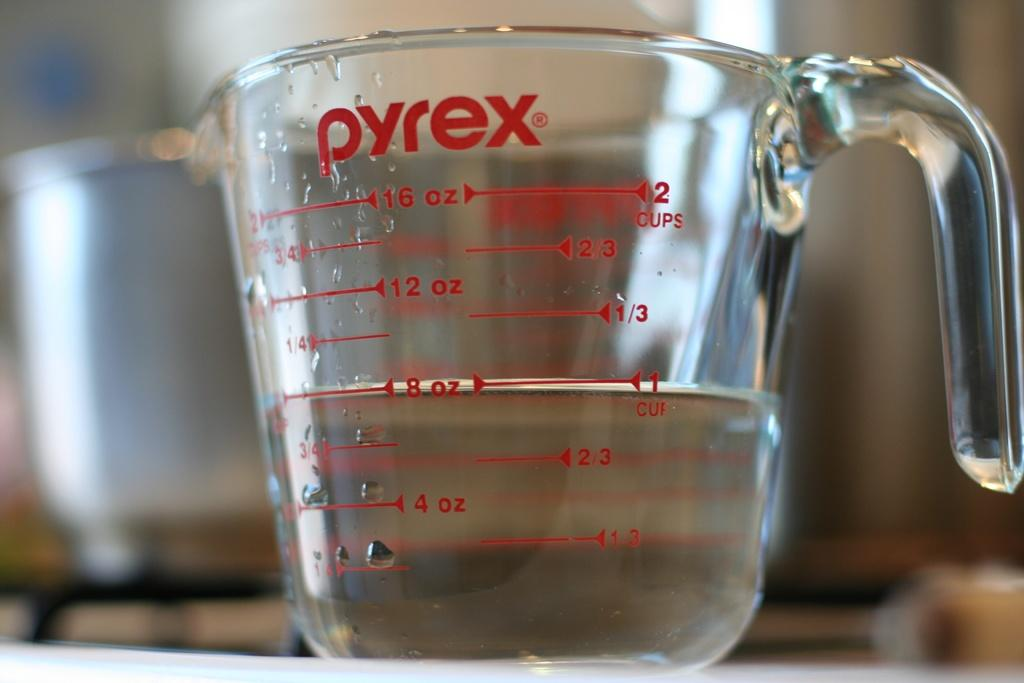<image>
Describe the image concisely. A pyrex measuring cup is filled to 8 ounces. 